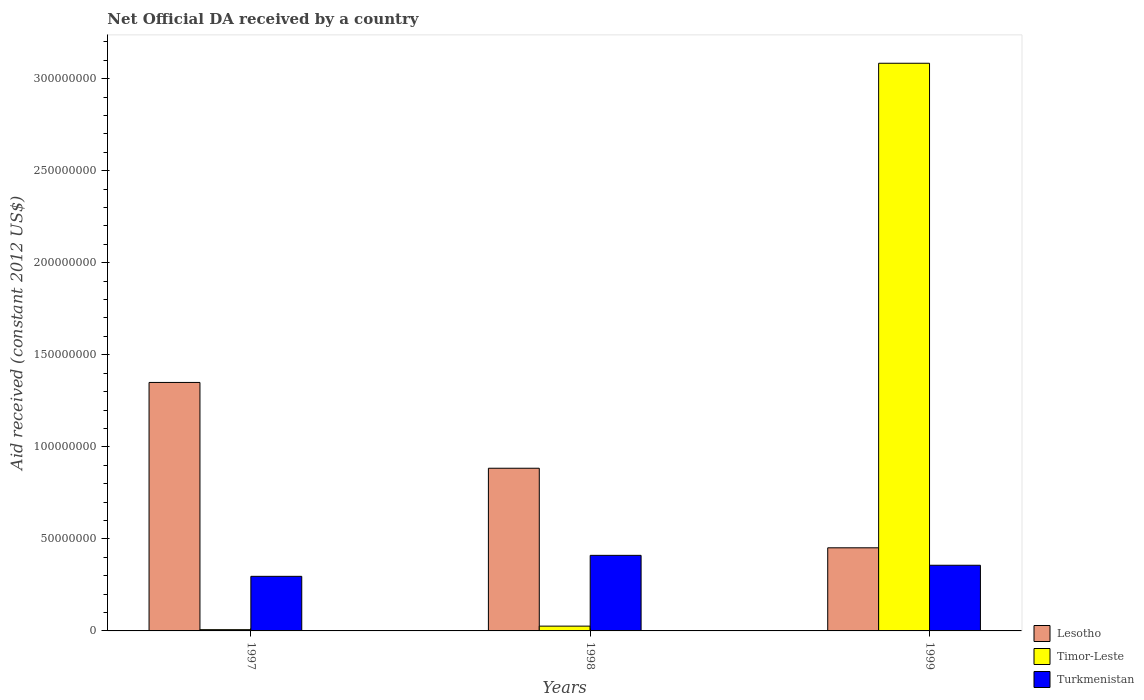Are the number of bars per tick equal to the number of legend labels?
Your answer should be compact. Yes. How many bars are there on the 3rd tick from the right?
Your answer should be very brief. 3. In how many cases, is the number of bars for a given year not equal to the number of legend labels?
Provide a short and direct response. 0. What is the net official development assistance aid received in Timor-Leste in 1998?
Give a very brief answer. 2.60e+06. Across all years, what is the maximum net official development assistance aid received in Timor-Leste?
Give a very brief answer. 3.08e+08. Across all years, what is the minimum net official development assistance aid received in Timor-Leste?
Offer a very short reply. 6.80e+05. What is the total net official development assistance aid received in Turkmenistan in the graph?
Keep it short and to the point. 1.06e+08. What is the difference between the net official development assistance aid received in Turkmenistan in 1997 and that in 1999?
Keep it short and to the point. -6.02e+06. What is the difference between the net official development assistance aid received in Timor-Leste in 1998 and the net official development assistance aid received in Lesotho in 1999?
Provide a succinct answer. -4.26e+07. What is the average net official development assistance aid received in Timor-Leste per year?
Keep it short and to the point. 1.04e+08. In the year 1999, what is the difference between the net official development assistance aid received in Timor-Leste and net official development assistance aid received in Turkmenistan?
Offer a very short reply. 2.73e+08. What is the ratio of the net official development assistance aid received in Timor-Leste in 1997 to that in 1998?
Offer a terse response. 0.26. Is the net official development assistance aid received in Lesotho in 1997 less than that in 1998?
Make the answer very short. No. Is the difference between the net official development assistance aid received in Timor-Leste in 1997 and 1999 greater than the difference between the net official development assistance aid received in Turkmenistan in 1997 and 1999?
Provide a short and direct response. No. What is the difference between the highest and the second highest net official development assistance aid received in Timor-Leste?
Give a very brief answer. 3.06e+08. What is the difference between the highest and the lowest net official development assistance aid received in Turkmenistan?
Provide a succinct answer. 1.14e+07. What does the 3rd bar from the left in 1999 represents?
Give a very brief answer. Turkmenistan. What does the 1st bar from the right in 1999 represents?
Offer a terse response. Turkmenistan. How many bars are there?
Provide a short and direct response. 9. Are all the bars in the graph horizontal?
Provide a succinct answer. No. How many years are there in the graph?
Your answer should be compact. 3. What is the difference between two consecutive major ticks on the Y-axis?
Provide a succinct answer. 5.00e+07. Does the graph contain grids?
Give a very brief answer. No. Where does the legend appear in the graph?
Give a very brief answer. Bottom right. How are the legend labels stacked?
Your response must be concise. Vertical. What is the title of the graph?
Your answer should be very brief. Net Official DA received by a country. What is the label or title of the Y-axis?
Keep it short and to the point. Aid received (constant 2012 US$). What is the Aid received (constant 2012 US$) of Lesotho in 1997?
Your answer should be compact. 1.35e+08. What is the Aid received (constant 2012 US$) in Timor-Leste in 1997?
Give a very brief answer. 6.80e+05. What is the Aid received (constant 2012 US$) in Turkmenistan in 1997?
Provide a short and direct response. 2.96e+07. What is the Aid received (constant 2012 US$) of Lesotho in 1998?
Keep it short and to the point. 8.84e+07. What is the Aid received (constant 2012 US$) in Timor-Leste in 1998?
Make the answer very short. 2.60e+06. What is the Aid received (constant 2012 US$) in Turkmenistan in 1998?
Your answer should be compact. 4.10e+07. What is the Aid received (constant 2012 US$) of Lesotho in 1999?
Offer a very short reply. 4.52e+07. What is the Aid received (constant 2012 US$) in Timor-Leste in 1999?
Provide a short and direct response. 3.08e+08. What is the Aid received (constant 2012 US$) of Turkmenistan in 1999?
Offer a very short reply. 3.57e+07. Across all years, what is the maximum Aid received (constant 2012 US$) of Lesotho?
Ensure brevity in your answer.  1.35e+08. Across all years, what is the maximum Aid received (constant 2012 US$) of Timor-Leste?
Make the answer very short. 3.08e+08. Across all years, what is the maximum Aid received (constant 2012 US$) in Turkmenistan?
Ensure brevity in your answer.  4.10e+07. Across all years, what is the minimum Aid received (constant 2012 US$) in Lesotho?
Provide a succinct answer. 4.52e+07. Across all years, what is the minimum Aid received (constant 2012 US$) in Timor-Leste?
Ensure brevity in your answer.  6.80e+05. Across all years, what is the minimum Aid received (constant 2012 US$) in Turkmenistan?
Ensure brevity in your answer.  2.96e+07. What is the total Aid received (constant 2012 US$) of Lesotho in the graph?
Offer a terse response. 2.69e+08. What is the total Aid received (constant 2012 US$) of Timor-Leste in the graph?
Offer a terse response. 3.12e+08. What is the total Aid received (constant 2012 US$) of Turkmenistan in the graph?
Your answer should be very brief. 1.06e+08. What is the difference between the Aid received (constant 2012 US$) of Lesotho in 1997 and that in 1998?
Make the answer very short. 4.66e+07. What is the difference between the Aid received (constant 2012 US$) in Timor-Leste in 1997 and that in 1998?
Provide a succinct answer. -1.92e+06. What is the difference between the Aid received (constant 2012 US$) in Turkmenistan in 1997 and that in 1998?
Provide a short and direct response. -1.14e+07. What is the difference between the Aid received (constant 2012 US$) of Lesotho in 1997 and that in 1999?
Offer a terse response. 8.98e+07. What is the difference between the Aid received (constant 2012 US$) in Timor-Leste in 1997 and that in 1999?
Your answer should be very brief. -3.08e+08. What is the difference between the Aid received (constant 2012 US$) in Turkmenistan in 1997 and that in 1999?
Provide a succinct answer. -6.02e+06. What is the difference between the Aid received (constant 2012 US$) in Lesotho in 1998 and that in 1999?
Keep it short and to the point. 4.32e+07. What is the difference between the Aid received (constant 2012 US$) of Timor-Leste in 1998 and that in 1999?
Provide a short and direct response. -3.06e+08. What is the difference between the Aid received (constant 2012 US$) of Turkmenistan in 1998 and that in 1999?
Keep it short and to the point. 5.38e+06. What is the difference between the Aid received (constant 2012 US$) in Lesotho in 1997 and the Aid received (constant 2012 US$) in Timor-Leste in 1998?
Ensure brevity in your answer.  1.32e+08. What is the difference between the Aid received (constant 2012 US$) of Lesotho in 1997 and the Aid received (constant 2012 US$) of Turkmenistan in 1998?
Provide a short and direct response. 9.39e+07. What is the difference between the Aid received (constant 2012 US$) of Timor-Leste in 1997 and the Aid received (constant 2012 US$) of Turkmenistan in 1998?
Offer a terse response. -4.04e+07. What is the difference between the Aid received (constant 2012 US$) of Lesotho in 1997 and the Aid received (constant 2012 US$) of Timor-Leste in 1999?
Your answer should be very brief. -1.73e+08. What is the difference between the Aid received (constant 2012 US$) in Lesotho in 1997 and the Aid received (constant 2012 US$) in Turkmenistan in 1999?
Offer a very short reply. 9.93e+07. What is the difference between the Aid received (constant 2012 US$) of Timor-Leste in 1997 and the Aid received (constant 2012 US$) of Turkmenistan in 1999?
Ensure brevity in your answer.  -3.50e+07. What is the difference between the Aid received (constant 2012 US$) in Lesotho in 1998 and the Aid received (constant 2012 US$) in Timor-Leste in 1999?
Make the answer very short. -2.20e+08. What is the difference between the Aid received (constant 2012 US$) of Lesotho in 1998 and the Aid received (constant 2012 US$) of Turkmenistan in 1999?
Your answer should be compact. 5.27e+07. What is the difference between the Aid received (constant 2012 US$) in Timor-Leste in 1998 and the Aid received (constant 2012 US$) in Turkmenistan in 1999?
Offer a terse response. -3.31e+07. What is the average Aid received (constant 2012 US$) of Lesotho per year?
Ensure brevity in your answer.  8.95e+07. What is the average Aid received (constant 2012 US$) in Timor-Leste per year?
Your answer should be very brief. 1.04e+08. What is the average Aid received (constant 2012 US$) in Turkmenistan per year?
Offer a very short reply. 3.55e+07. In the year 1997, what is the difference between the Aid received (constant 2012 US$) of Lesotho and Aid received (constant 2012 US$) of Timor-Leste?
Give a very brief answer. 1.34e+08. In the year 1997, what is the difference between the Aid received (constant 2012 US$) in Lesotho and Aid received (constant 2012 US$) in Turkmenistan?
Provide a succinct answer. 1.05e+08. In the year 1997, what is the difference between the Aid received (constant 2012 US$) of Timor-Leste and Aid received (constant 2012 US$) of Turkmenistan?
Your answer should be compact. -2.90e+07. In the year 1998, what is the difference between the Aid received (constant 2012 US$) in Lesotho and Aid received (constant 2012 US$) in Timor-Leste?
Offer a very short reply. 8.58e+07. In the year 1998, what is the difference between the Aid received (constant 2012 US$) of Lesotho and Aid received (constant 2012 US$) of Turkmenistan?
Provide a succinct answer. 4.73e+07. In the year 1998, what is the difference between the Aid received (constant 2012 US$) of Timor-Leste and Aid received (constant 2012 US$) of Turkmenistan?
Provide a succinct answer. -3.84e+07. In the year 1999, what is the difference between the Aid received (constant 2012 US$) in Lesotho and Aid received (constant 2012 US$) in Timor-Leste?
Keep it short and to the point. -2.63e+08. In the year 1999, what is the difference between the Aid received (constant 2012 US$) in Lesotho and Aid received (constant 2012 US$) in Turkmenistan?
Your answer should be very brief. 9.48e+06. In the year 1999, what is the difference between the Aid received (constant 2012 US$) in Timor-Leste and Aid received (constant 2012 US$) in Turkmenistan?
Keep it short and to the point. 2.73e+08. What is the ratio of the Aid received (constant 2012 US$) in Lesotho in 1997 to that in 1998?
Make the answer very short. 1.53. What is the ratio of the Aid received (constant 2012 US$) of Timor-Leste in 1997 to that in 1998?
Give a very brief answer. 0.26. What is the ratio of the Aid received (constant 2012 US$) of Turkmenistan in 1997 to that in 1998?
Offer a very short reply. 0.72. What is the ratio of the Aid received (constant 2012 US$) of Lesotho in 1997 to that in 1999?
Provide a short and direct response. 2.99. What is the ratio of the Aid received (constant 2012 US$) in Timor-Leste in 1997 to that in 1999?
Offer a very short reply. 0. What is the ratio of the Aid received (constant 2012 US$) in Turkmenistan in 1997 to that in 1999?
Give a very brief answer. 0.83. What is the ratio of the Aid received (constant 2012 US$) in Lesotho in 1998 to that in 1999?
Keep it short and to the point. 1.96. What is the ratio of the Aid received (constant 2012 US$) of Timor-Leste in 1998 to that in 1999?
Ensure brevity in your answer.  0.01. What is the ratio of the Aid received (constant 2012 US$) of Turkmenistan in 1998 to that in 1999?
Your response must be concise. 1.15. What is the difference between the highest and the second highest Aid received (constant 2012 US$) of Lesotho?
Give a very brief answer. 4.66e+07. What is the difference between the highest and the second highest Aid received (constant 2012 US$) of Timor-Leste?
Offer a terse response. 3.06e+08. What is the difference between the highest and the second highest Aid received (constant 2012 US$) of Turkmenistan?
Keep it short and to the point. 5.38e+06. What is the difference between the highest and the lowest Aid received (constant 2012 US$) of Lesotho?
Your response must be concise. 8.98e+07. What is the difference between the highest and the lowest Aid received (constant 2012 US$) in Timor-Leste?
Offer a terse response. 3.08e+08. What is the difference between the highest and the lowest Aid received (constant 2012 US$) in Turkmenistan?
Offer a very short reply. 1.14e+07. 